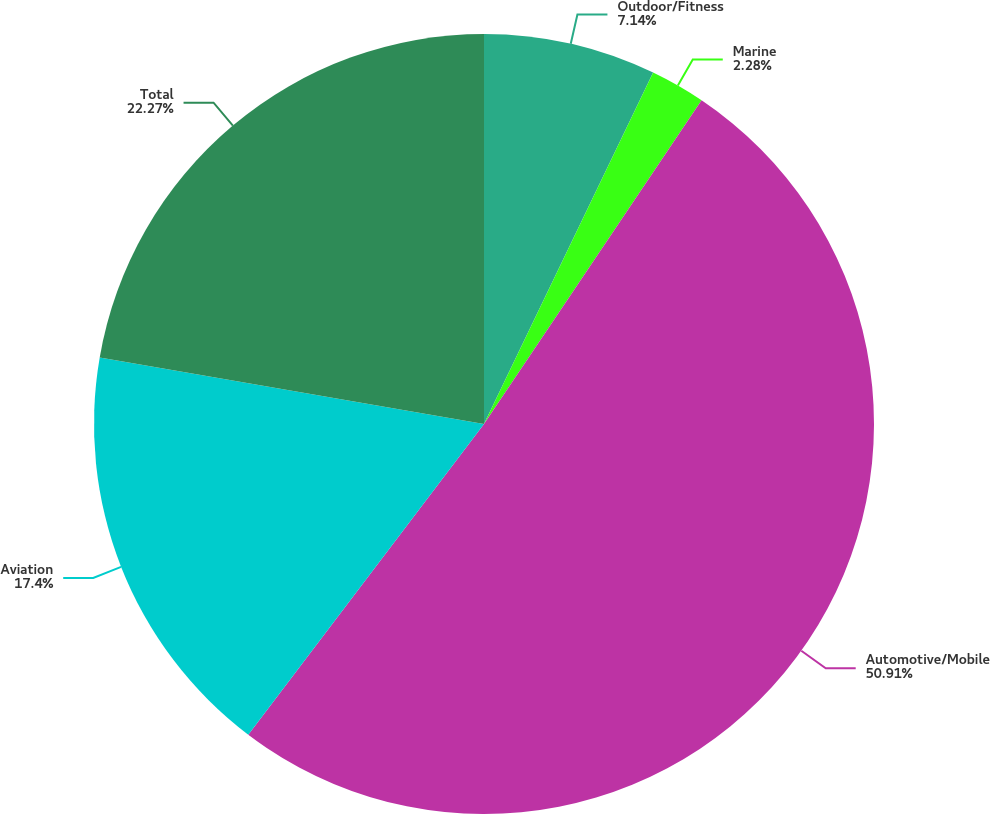Convert chart. <chart><loc_0><loc_0><loc_500><loc_500><pie_chart><fcel>Outdoor/Fitness<fcel>Marine<fcel>Automotive/Mobile<fcel>Aviation<fcel>Total<nl><fcel>7.14%<fcel>2.28%<fcel>50.91%<fcel>17.4%<fcel>22.27%<nl></chart> 